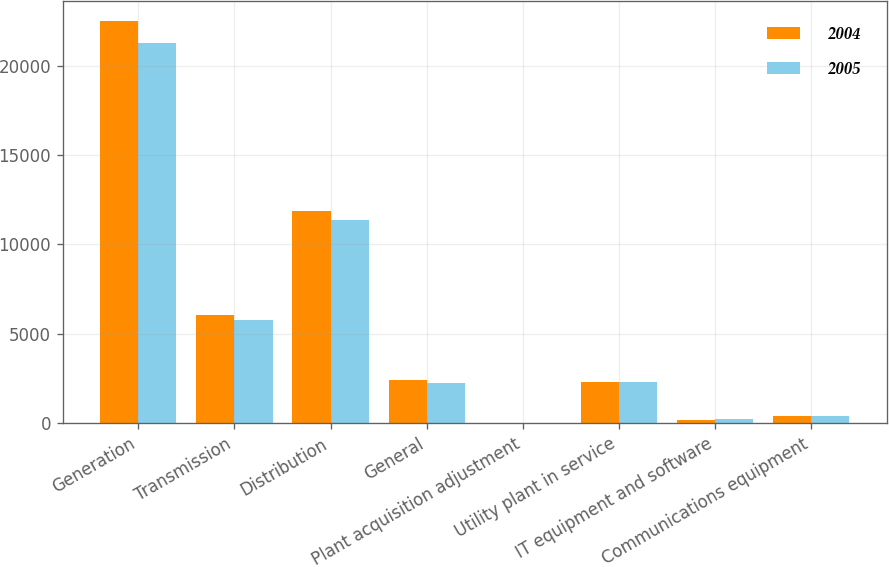Convert chart to OTSL. <chart><loc_0><loc_0><loc_500><loc_500><stacked_bar_chart><ecel><fcel>Generation<fcel>Transmission<fcel>Distribution<fcel>General<fcel>Plant acquisition adjustment<fcel>Utility plant in service<fcel>IT equipment and software<fcel>Communications equipment<nl><fcel>2004<fcel>22490<fcel>6031<fcel>11894<fcel>2393<fcel>41<fcel>2330.5<fcel>211<fcel>431<nl><fcel>2005<fcel>21262<fcel>5770<fcel>11368<fcel>2268<fcel>42<fcel>2330.5<fcel>214<fcel>404<nl></chart> 